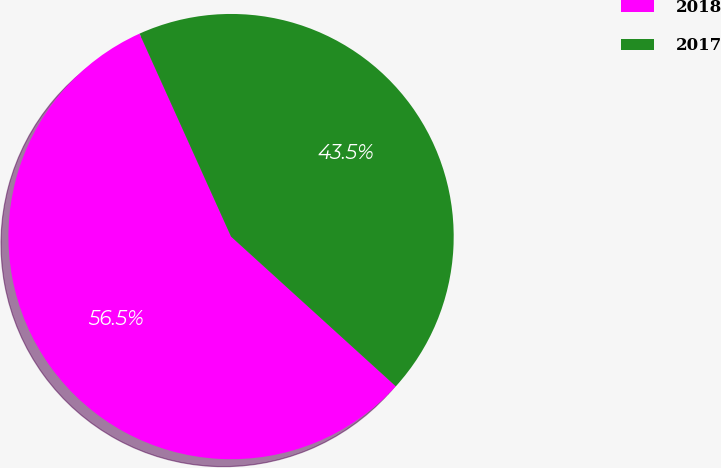Convert chart. <chart><loc_0><loc_0><loc_500><loc_500><pie_chart><fcel>2018<fcel>2017<nl><fcel>56.52%<fcel>43.48%<nl></chart> 